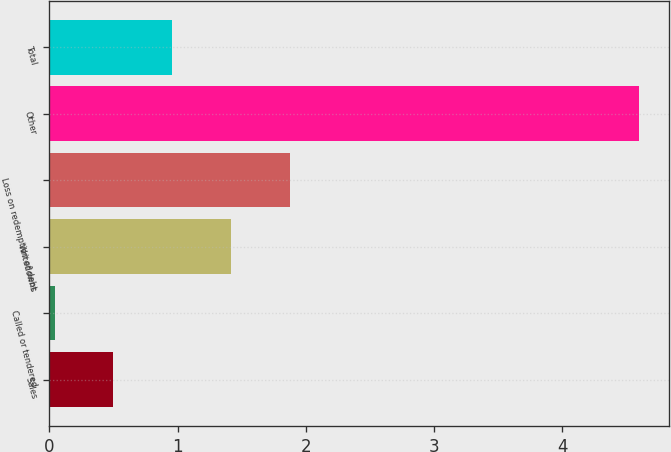Convert chart. <chart><loc_0><loc_0><loc_500><loc_500><bar_chart><fcel>Sales<fcel>Called or tendered<fcel>Writedowns<fcel>Loss on redemption of debt<fcel>Other<fcel>Total<nl><fcel>0.5<fcel>0.04<fcel>1.42<fcel>1.88<fcel>4.6<fcel>0.96<nl></chart> 